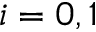<formula> <loc_0><loc_0><loc_500><loc_500>i = 0 , 1</formula> 